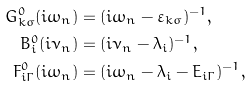<formula> <loc_0><loc_0><loc_500><loc_500>G ^ { 0 } _ { { k } \sigma } ( i \omega _ { n } ) & = ( i \omega _ { n } - \varepsilon _ { k \sigma } ) ^ { - 1 } , \\ B ^ { 0 } _ { i } ( i \nu _ { n } ) & = ( i \nu _ { n } - \lambda _ { i } ) ^ { - 1 } , \\ F ^ { 0 } _ { i \Gamma } ( i \omega _ { n } ) & = ( i \omega _ { n } - \lambda _ { i } - E _ { i \Gamma } ) ^ { - 1 } ,</formula> 